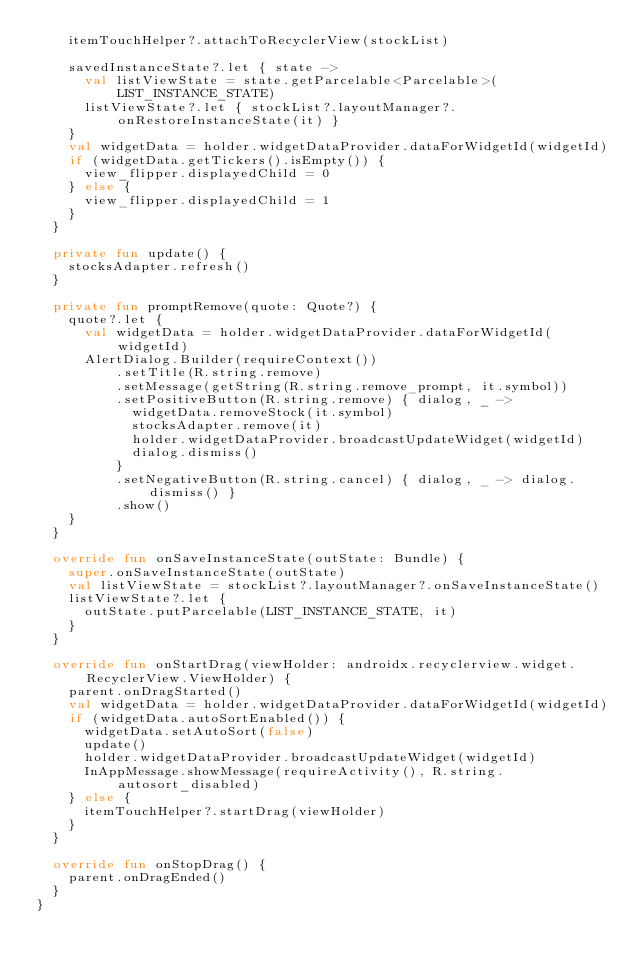<code> <loc_0><loc_0><loc_500><loc_500><_Kotlin_>    itemTouchHelper?.attachToRecyclerView(stockList)

    savedInstanceState?.let { state ->
      val listViewState = state.getParcelable<Parcelable>(LIST_INSTANCE_STATE)
      listViewState?.let { stockList?.layoutManager?.onRestoreInstanceState(it) }
    }
    val widgetData = holder.widgetDataProvider.dataForWidgetId(widgetId)
    if (widgetData.getTickers().isEmpty()) {
      view_flipper.displayedChild = 0
    } else {
      view_flipper.displayedChild = 1
    }
  }

  private fun update() {
    stocksAdapter.refresh()
  }

  private fun promptRemove(quote: Quote?) {
    quote?.let {
      val widgetData = holder.widgetDataProvider.dataForWidgetId(widgetId)
      AlertDialog.Builder(requireContext())
          .setTitle(R.string.remove)
          .setMessage(getString(R.string.remove_prompt, it.symbol))
          .setPositiveButton(R.string.remove) { dialog, _ ->
            widgetData.removeStock(it.symbol)
            stocksAdapter.remove(it)
            holder.widgetDataProvider.broadcastUpdateWidget(widgetId)
            dialog.dismiss()
          }
          .setNegativeButton(R.string.cancel) { dialog, _ -> dialog.dismiss() }
          .show()
    }
  }

  override fun onSaveInstanceState(outState: Bundle) {
    super.onSaveInstanceState(outState)
    val listViewState = stockList?.layoutManager?.onSaveInstanceState()
    listViewState?.let {
      outState.putParcelable(LIST_INSTANCE_STATE, it)
    }
  }

  override fun onStartDrag(viewHolder: androidx.recyclerview.widget.RecyclerView.ViewHolder) {
    parent.onDragStarted()
    val widgetData = holder.widgetDataProvider.dataForWidgetId(widgetId)
    if (widgetData.autoSortEnabled()) {
      widgetData.setAutoSort(false)
      update()
      holder.widgetDataProvider.broadcastUpdateWidget(widgetId)
      InAppMessage.showMessage(requireActivity(), R.string.autosort_disabled)
    } else {
      itemTouchHelper?.startDrag(viewHolder)
    }
  }

  override fun onStopDrag() {
    parent.onDragEnded()
  }
}</code> 